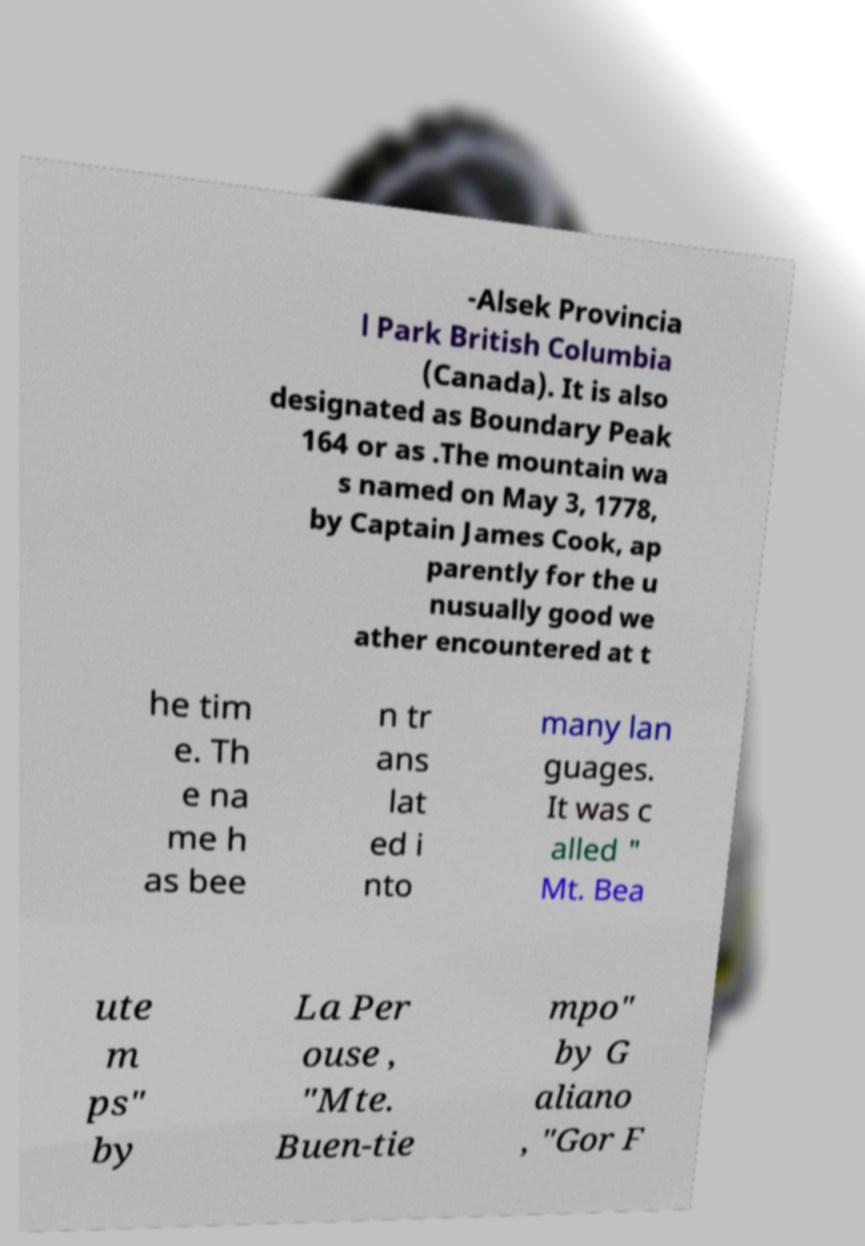There's text embedded in this image that I need extracted. Can you transcribe it verbatim? -Alsek Provincia l Park British Columbia (Canada). It is also designated as Boundary Peak 164 or as .The mountain wa s named on May 3, 1778, by Captain James Cook, ap parently for the u nusually good we ather encountered at t he tim e. Th e na me h as bee n tr ans lat ed i nto many lan guages. It was c alled " Mt. Bea ute m ps" by La Per ouse , "Mte. Buen-tie mpo" by G aliano , "Gor F 